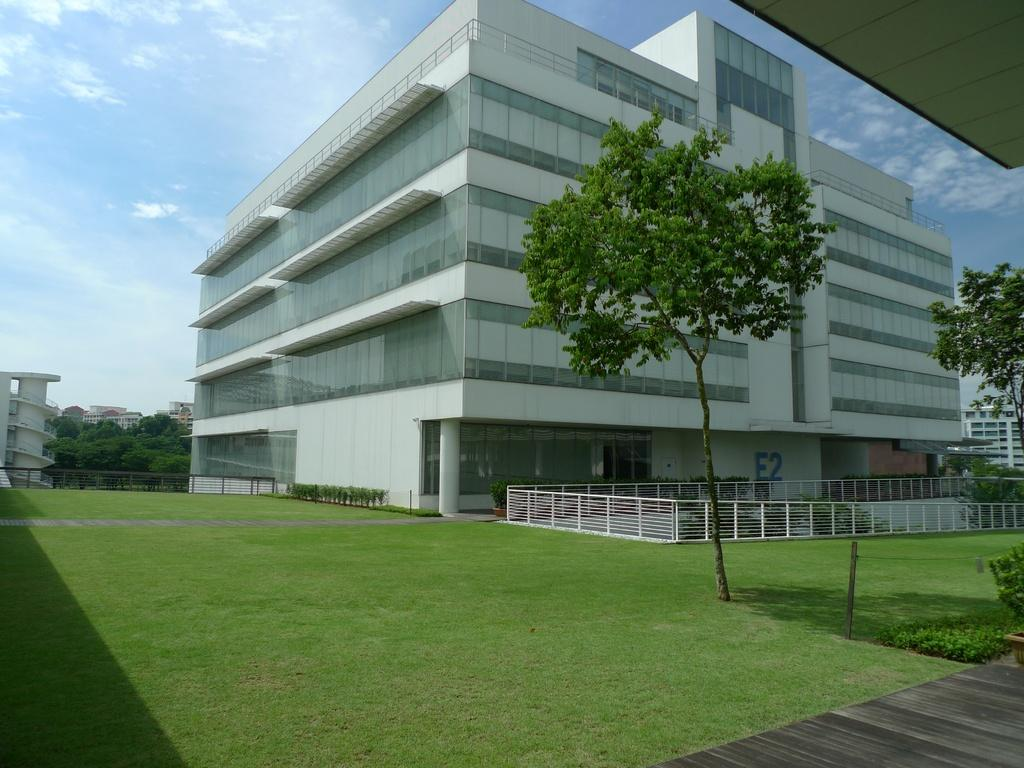What type of structures can be seen in the image? There are many buildings in the image. What is the purpose of the barrier in the image? There is a fence in the image, which serves as a barrier or boundary. What type of vegetation is present in the image? There is grass, trees, and a plant in the image. What type of surface can be used for walking or running in the image? There is a footpath and a path in the image, which can be used for walking or running. How would you describe the sky in the image? The sky is cloudy and pale blue in the image. Where is the lumber being stored in the image? There is no lumber present in the image. What type of liquid is being boiled in the kettle in the image? There is no kettle present in the image. 